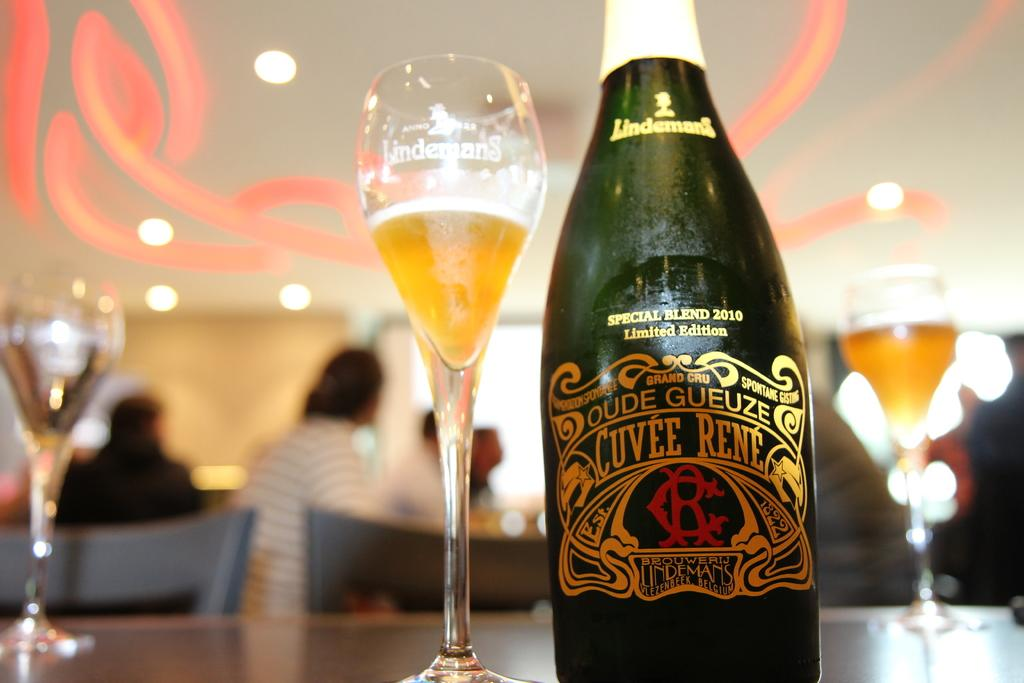<image>
Present a compact description of the photo's key features. A bottle of Oude Gueze Cuvee Rene Champagne. 